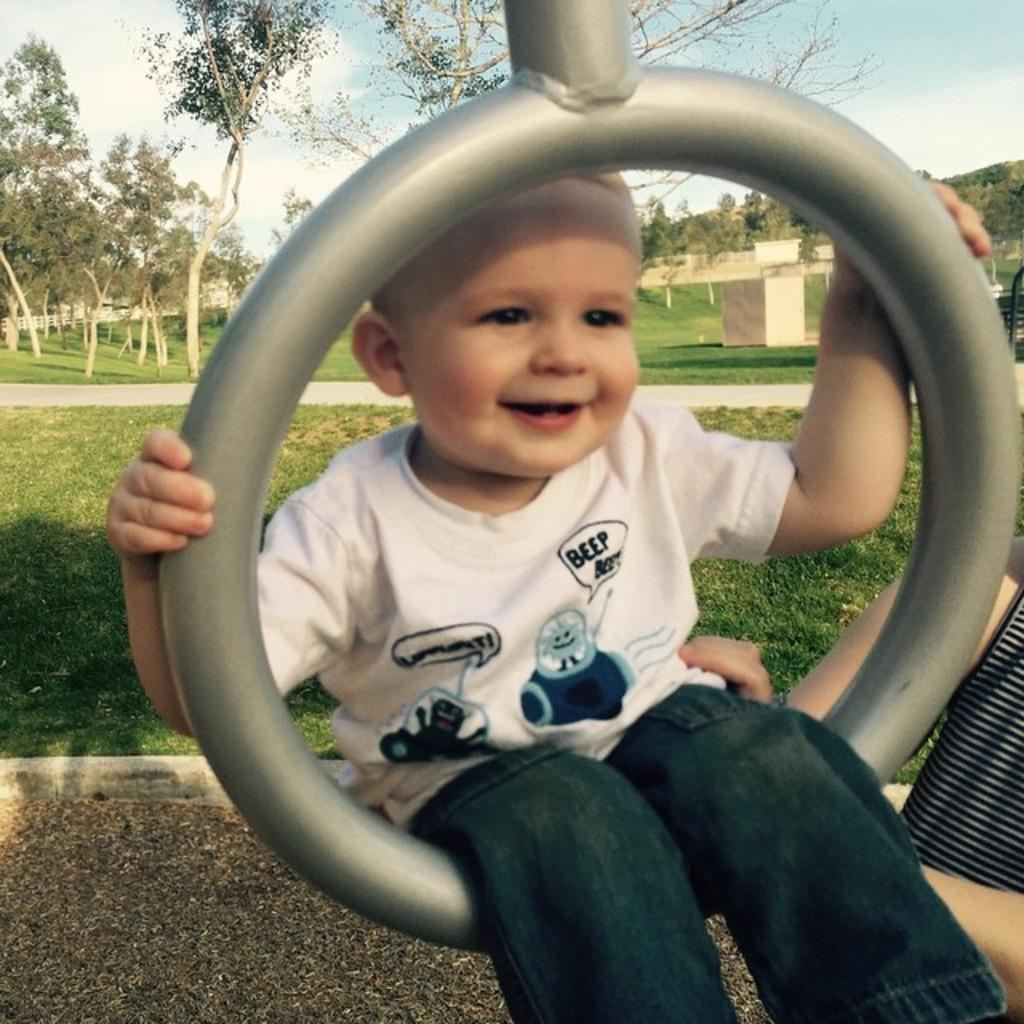What is the main subject of the image? There is a baby in the middle of the image. What is the baby's expression in the image? The baby is smiling. What type of natural environment is visible in the background of the image? There is grass and trees in the background of the image. What fact can be learned about the baby's use of a field in the image? There is no mention of a field in the image, and therefore no information about the baby's use of it can be provided. 